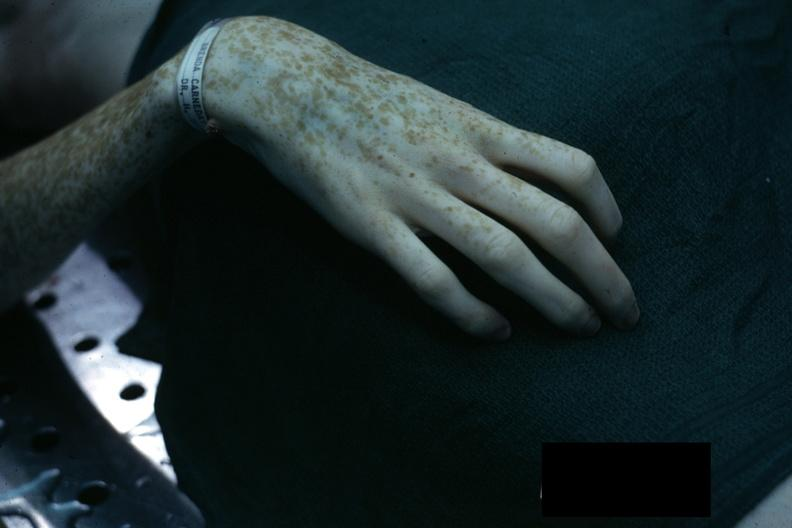does this image show excellent example of marfans syndrome?
Answer the question using a single word or phrase. Yes 